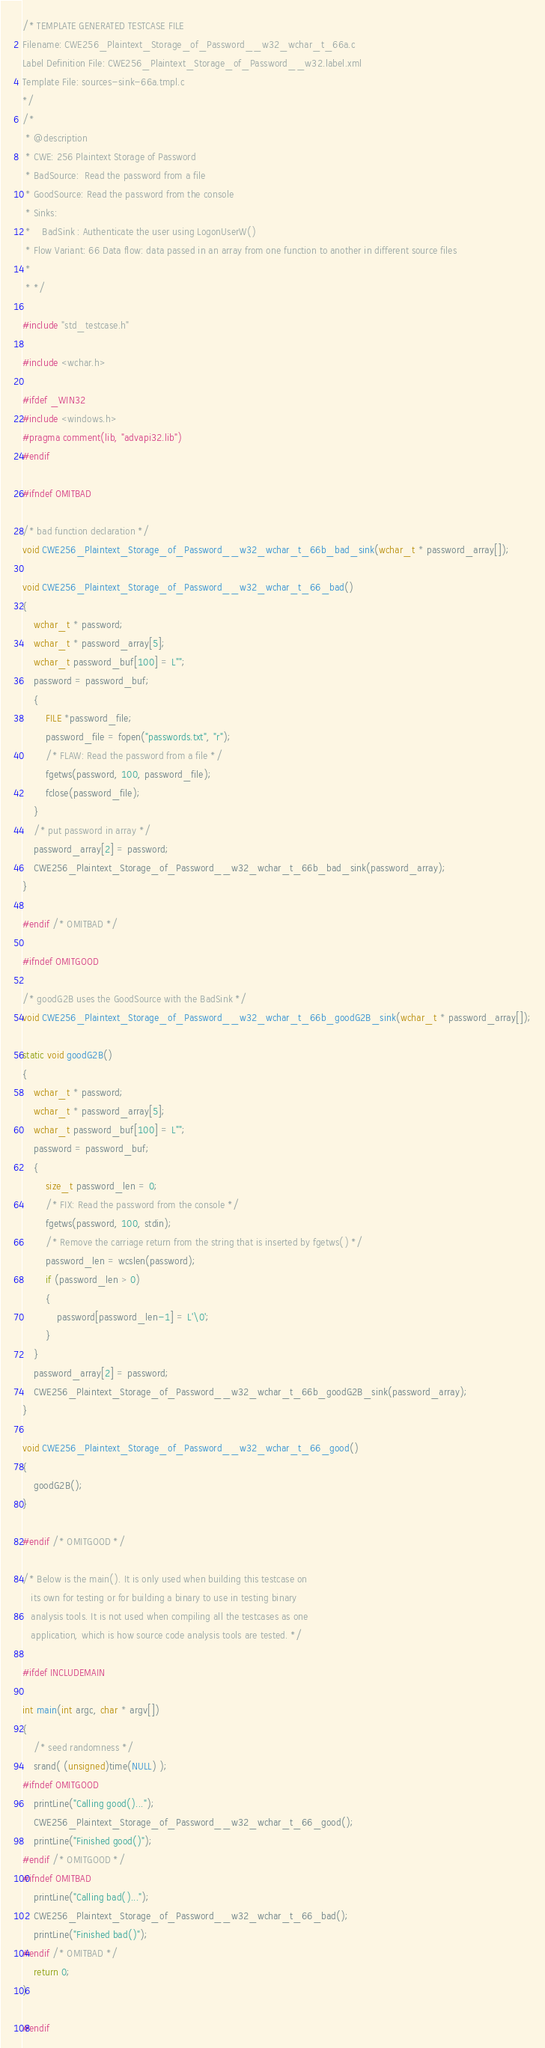Convert code to text. <code><loc_0><loc_0><loc_500><loc_500><_C_>/* TEMPLATE GENERATED TESTCASE FILE
Filename: CWE256_Plaintext_Storage_of_Password__w32_wchar_t_66a.c
Label Definition File: CWE256_Plaintext_Storage_of_Password__w32.label.xml
Template File: sources-sink-66a.tmpl.c
*/
/*
 * @description
 * CWE: 256 Plaintext Storage of Password
 * BadSource:  Read the password from a file
 * GoodSource: Read the password from the console
 * Sinks:
 *    BadSink : Authenticate the user using LogonUserW()
 * Flow Variant: 66 Data flow: data passed in an array from one function to another in different source files
 *
 * */

#include "std_testcase.h"

#include <wchar.h>

#ifdef _WIN32
#include <windows.h>
#pragma comment(lib, "advapi32.lib")
#endif

#ifndef OMITBAD

/* bad function declaration */
void CWE256_Plaintext_Storage_of_Password__w32_wchar_t_66b_bad_sink(wchar_t * password_array[]);

void CWE256_Plaintext_Storage_of_Password__w32_wchar_t_66_bad()
{
    wchar_t * password;
    wchar_t * password_array[5];
    wchar_t password_buf[100] = L"";
    password = password_buf;
    {
        FILE *password_file;
        password_file = fopen("passwords.txt", "r");
        /* FLAW: Read the password from a file */
        fgetws(password, 100, password_file);
        fclose(password_file);
    }
    /* put password in array */
    password_array[2] = password;
    CWE256_Plaintext_Storage_of_Password__w32_wchar_t_66b_bad_sink(password_array);
}

#endif /* OMITBAD */

#ifndef OMITGOOD

/* goodG2B uses the GoodSource with the BadSink */
void CWE256_Plaintext_Storage_of_Password__w32_wchar_t_66b_goodG2B_sink(wchar_t * password_array[]);

static void goodG2B()
{
    wchar_t * password;
    wchar_t * password_array[5];
    wchar_t password_buf[100] = L"";
    password = password_buf;
    {
        size_t password_len = 0;
        /* FIX: Read the password from the console */
        fgetws(password, 100, stdin);
        /* Remove the carriage return from the string that is inserted by fgetws() */
        password_len = wcslen(password);
        if (password_len > 0)
        {
            password[password_len-1] = L'\0';
        }
    }
    password_array[2] = password;
    CWE256_Plaintext_Storage_of_Password__w32_wchar_t_66b_goodG2B_sink(password_array);
}

void CWE256_Plaintext_Storage_of_Password__w32_wchar_t_66_good()
{
    goodG2B();
}

#endif /* OMITGOOD */

/* Below is the main(). It is only used when building this testcase on
   its own for testing or for building a binary to use in testing binary
   analysis tools. It is not used when compiling all the testcases as one
   application, which is how source code analysis tools are tested. */

#ifdef INCLUDEMAIN

int main(int argc, char * argv[])
{
    /* seed randomness */
    srand( (unsigned)time(NULL) );
#ifndef OMITGOOD
    printLine("Calling good()...");
    CWE256_Plaintext_Storage_of_Password__w32_wchar_t_66_good();
    printLine("Finished good()");
#endif /* OMITGOOD */
#ifndef OMITBAD
    printLine("Calling bad()...");
    CWE256_Plaintext_Storage_of_Password__w32_wchar_t_66_bad();
    printLine("Finished bad()");
#endif /* OMITBAD */
    return 0;
}

#endif
</code> 